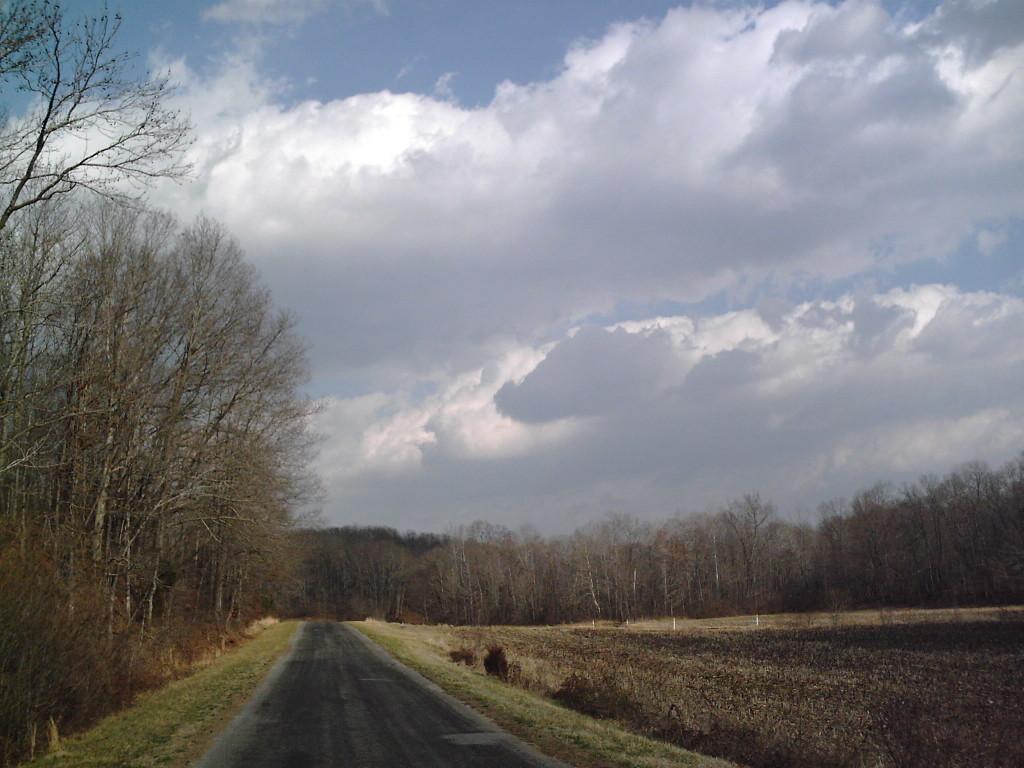Describe this image in one or two sentences. This image is clicked on the roads. At the bottom, there is a road. On the right, there is dry grass on the ground. In the background, there are many trees. At the top, there are clouds in the sky. 